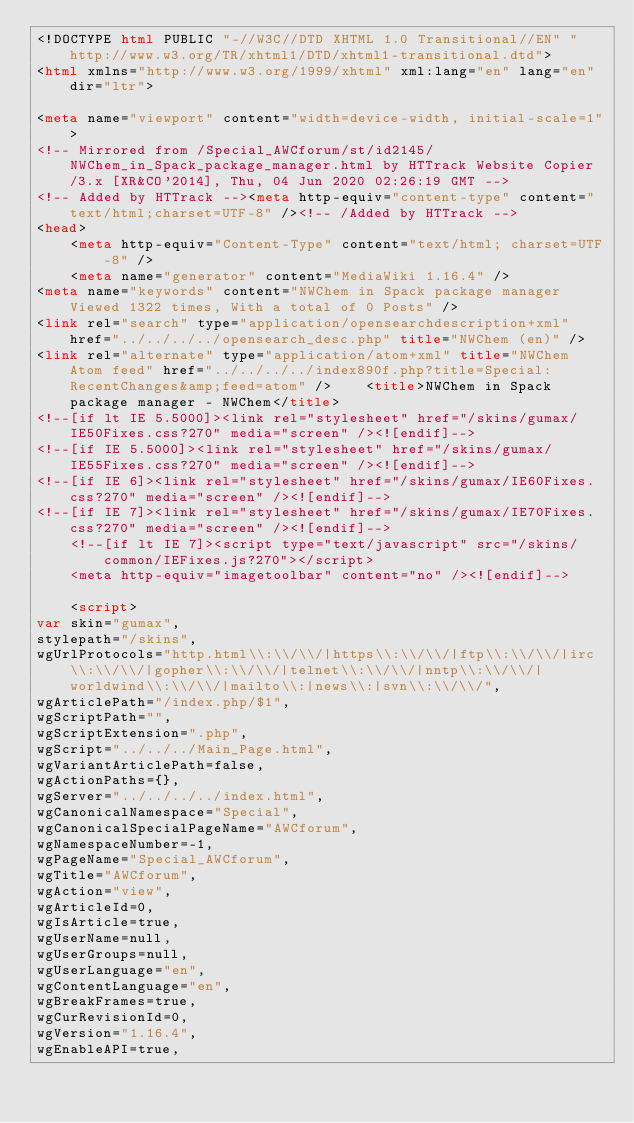Convert code to text. <code><loc_0><loc_0><loc_500><loc_500><_HTML_><!DOCTYPE html PUBLIC "-//W3C//DTD XHTML 1.0 Transitional//EN" "http://www.w3.org/TR/xhtml1/DTD/xhtml1-transitional.dtd">
<html xmlns="http://www.w3.org/1999/xhtml" xml:lang="en" lang="en" dir="ltr">
	
<meta name="viewport" content="width=device-width, initial-scale=1">
<!-- Mirrored from /Special_AWCforum/st/id2145/NWChem_in_Spack_package_manager.html by HTTrack Website Copier/3.x [XR&CO'2014], Thu, 04 Jun 2020 02:26:19 GMT -->
<!-- Added by HTTrack --><meta http-equiv="content-type" content="text/html;charset=UTF-8" /><!-- /Added by HTTrack -->
<head>
		<meta http-equiv="Content-Type" content="text/html; charset=UTF-8" />
		<meta name="generator" content="MediaWiki 1.16.4" />
<meta name="keywords" content="NWChem in Spack package manager Viewed 1322 times, With a total of 0 Posts" />
<link rel="search" type="application/opensearchdescription+xml" href="../../../../opensearch_desc.php" title="NWChem (en)" />
<link rel="alternate" type="application/atom+xml" title="NWChem Atom feed" href="../../../../index890f.php?title=Special:RecentChanges&amp;feed=atom" />		<title>NWChem in Spack package manager - NWChem</title>
<!--[if lt IE 5.5000]><link rel="stylesheet" href="/skins/gumax/IE50Fixes.css?270" media="screen" /><![endif]-->
<!--[if IE 5.5000]><link rel="stylesheet" href="/skins/gumax/IE55Fixes.css?270" media="screen" /><![endif]-->
<!--[if IE 6]><link rel="stylesheet" href="/skins/gumax/IE60Fixes.css?270" media="screen" /><![endif]-->
<!--[if IE 7]><link rel="stylesheet" href="/skins/gumax/IE70Fixes.css?270" media="screen" /><![endif]-->
		<!--[if lt IE 7]><script type="text/javascript" src="/skins/common/IEFixes.js?270"></script>
		<meta http-equiv="imagetoolbar" content="no" /><![endif]-->

		<script>
var skin="gumax",
stylepath="/skins",
wgUrlProtocols="http.html\\:\\/\\/|https\\:\\/\\/|ftp\\:\\/\\/|irc\\:\\/\\/|gopher\\:\\/\\/|telnet\\:\\/\\/|nntp\\:\\/\\/|worldwind\\:\\/\\/|mailto\\:|news\\:|svn\\:\\/\\/",
wgArticlePath="/index.php/$1",
wgScriptPath="",
wgScriptExtension=".php",
wgScript="../../../Main_Page.html",
wgVariantArticlePath=false,
wgActionPaths={},
wgServer="../../../../index.html",
wgCanonicalNamespace="Special",
wgCanonicalSpecialPageName="AWCforum",
wgNamespaceNumber=-1,
wgPageName="Special_AWCforum",
wgTitle="AWCforum",
wgAction="view",
wgArticleId=0,
wgIsArticle=true,
wgUserName=null,
wgUserGroups=null,
wgUserLanguage="en",
wgContentLanguage="en",
wgBreakFrames=true,
wgCurRevisionId=0,
wgVersion="1.16.4",
wgEnableAPI=true,</code> 